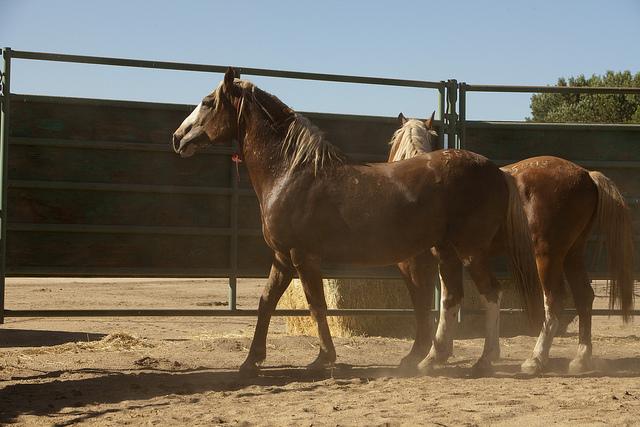How many horses are facing the other way?
Short answer required. 1. How many horses are there total?
Answer briefly. 2. How many animals are there?
Quick response, please. 2. Where are horses?
Concise answer only. Corral. Are the horses at home?
Give a very brief answer. Yes. 